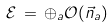<formula> <loc_0><loc_0><loc_500><loc_500>\mathcal { E } \, = \, \oplus _ { a } \mathcal { O } ( \vec { n } _ { a } )</formula> 